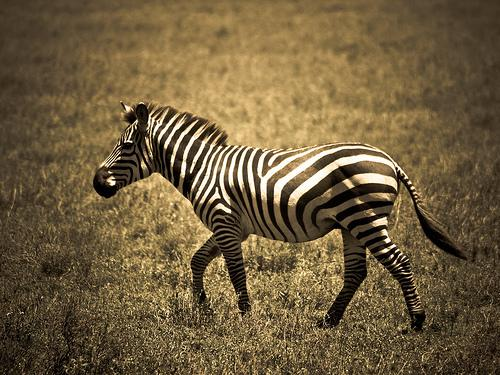Question: who is next to the zebra?
Choices:
A. A zookeeper.
B. No one.
C. A hunter.
D. A photographer.
Answer with the letter. Answer: B 